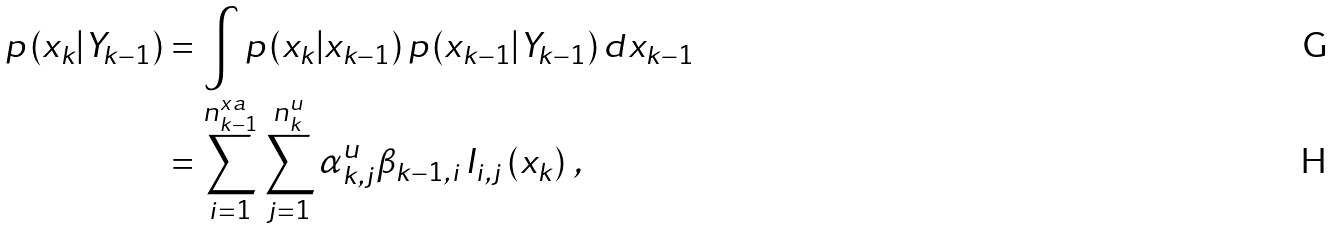<formula> <loc_0><loc_0><loc_500><loc_500>p \left ( x _ { k } | Y _ { k - 1 } \right ) & = \int p \left ( x _ { k } | x _ { k - 1 } \right ) p \left ( x _ { k - 1 } | Y _ { k - 1 } \right ) d x _ { k - 1 } \, \\ & = \sum _ { i = 1 } ^ { n _ { k - 1 } ^ { x a } } \sum _ { j = 1 } ^ { n _ { k } ^ { u } } \alpha _ { k , j } ^ { u } \beta _ { k - 1 , i } \, I _ { i , j } \left ( x _ { k } \right ) \, ,</formula> 